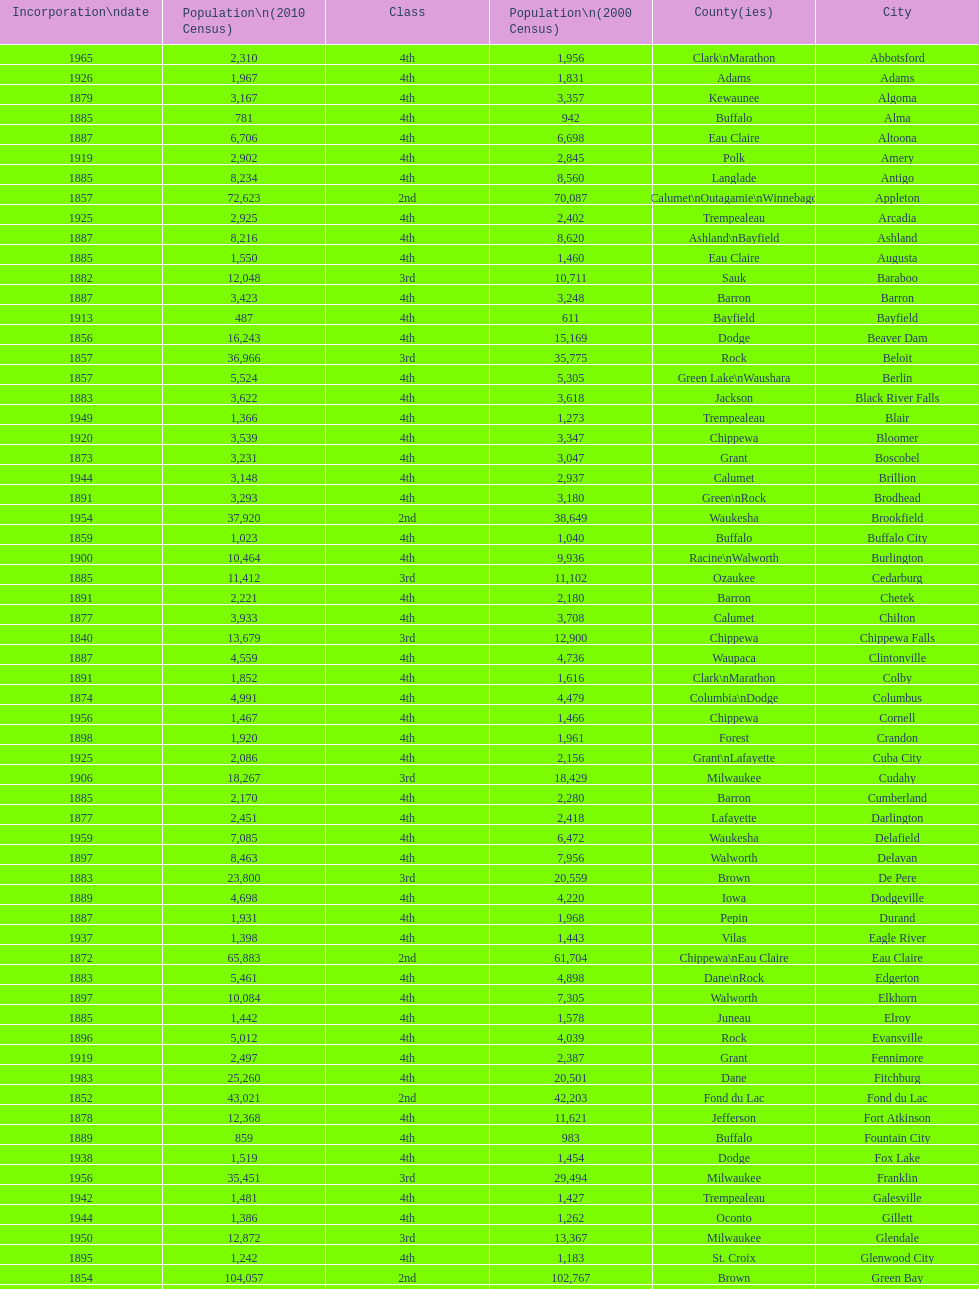What was the first city to be incorporated into wisconsin? Chippewa Falls. 